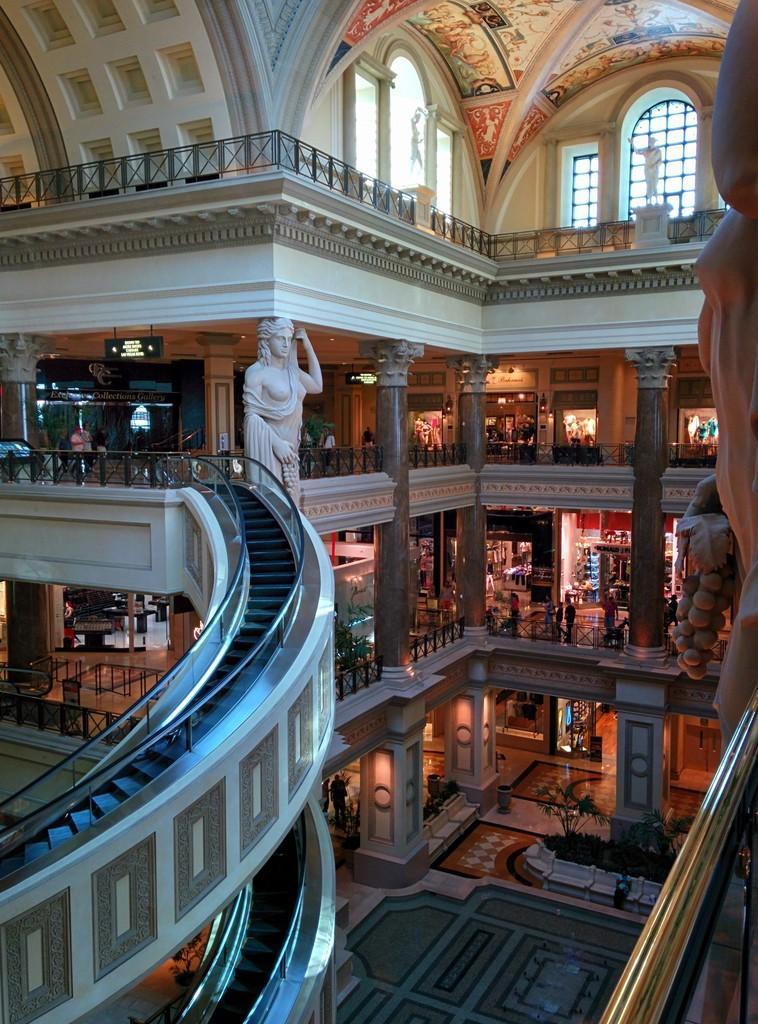In one or two sentences, can you explain what this image depicts? In this image we can see the inside view of a mall. In the middle of the image white color statue is present. Beside it elevators are present. 